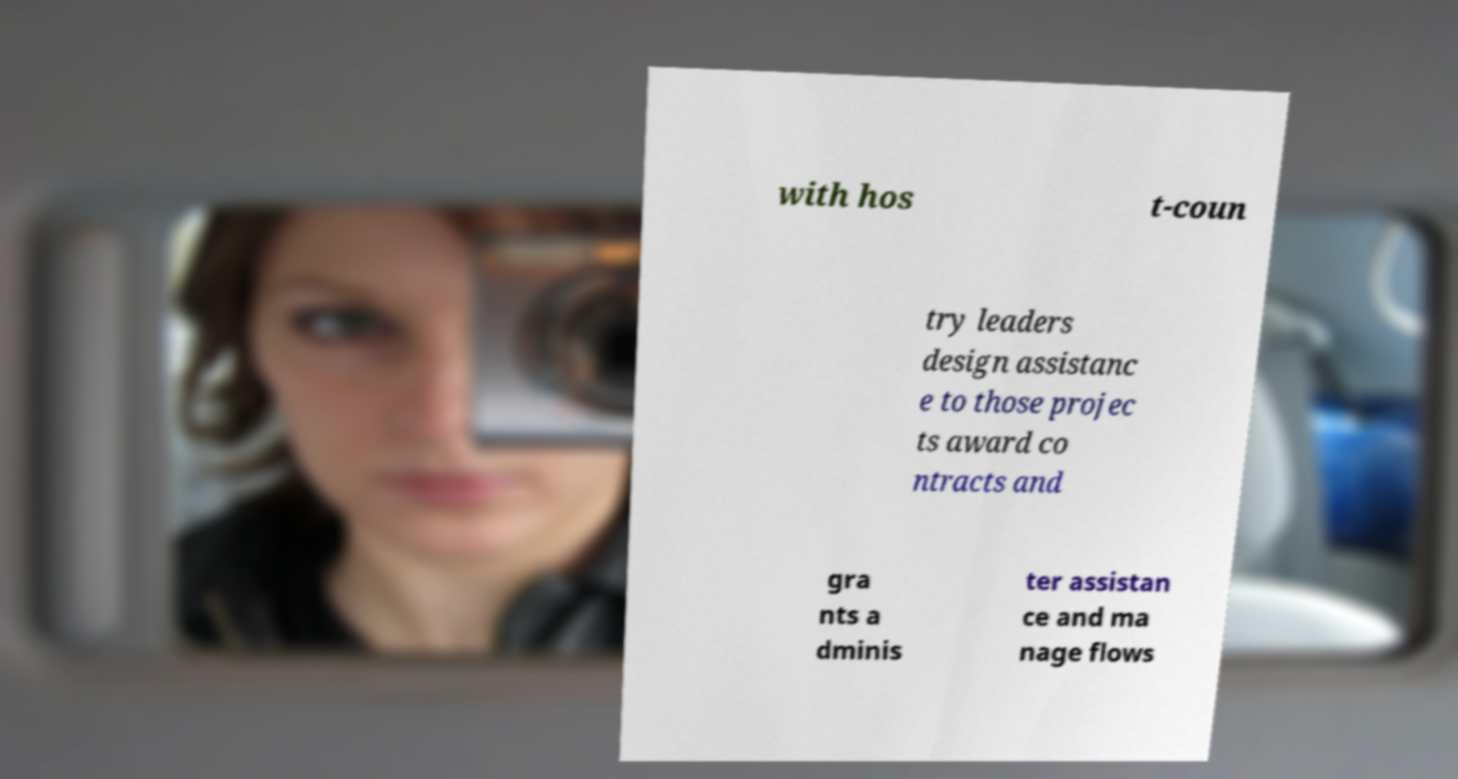Can you accurately transcribe the text from the provided image for me? with hos t-coun try leaders design assistanc e to those projec ts award co ntracts and gra nts a dminis ter assistan ce and ma nage flows 